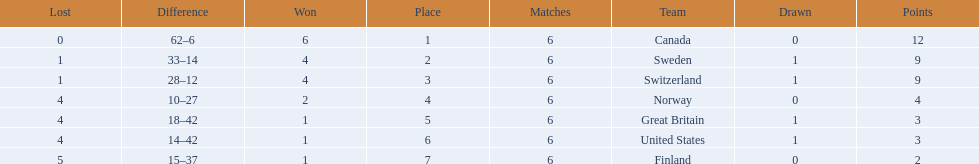Which are the two countries? Switzerland, Great Britain. What were the point totals for each of these countries? 9, 3. Of these point totals, which is better? 9. Which country earned this point total? Switzerland. 